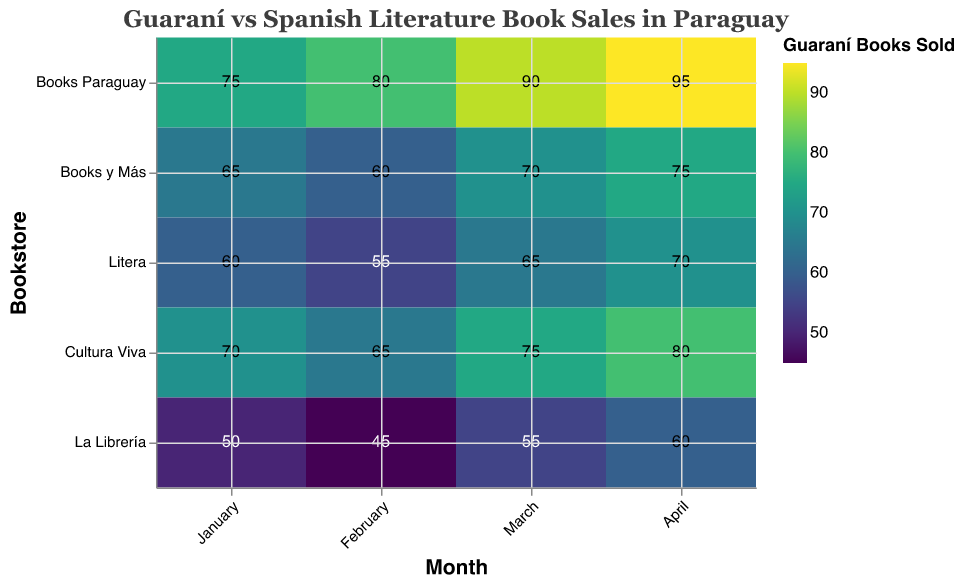What is the title of the chart? The title of the chart is displayed at the top and reads “Guaraní vs Spanish Literature Book Sales in Paraguay.”
Answer: Guaraní vs Spanish Literature Book Sales in Paraguay Which bookstore sold the most Guaraní literature books in April? Look for the highest rectangle in the column labeled "April". The bookstore with the highest value there is "Books Paraguay" with a value of 95.
Answer: Books Paraguay What is the total number of Guaraní literature books sold in January across all bookstores? Add the values for January in the Guaraní literature books sold column: 75 (Books Paraguay) + 65 (Books y Más) + 60 (Litera) + 70 (Cultura Viva) + 50 (La Librería) = 320.
Answer: 320 Which city shows the highest increase in Guaraní literature book sales from January to April? Calculate the difference for each city between January and April and find the largest increase: 
Asunción: 95 - 75 = 20
Encarnación: 75 - 65 = 10
San Lorenzo: 70 - 60 = 10
Ciudad del Este: 80 - 70 = 10
Luque: 60 - 50 = 10
Answer: Asunción Compared to January, how many more Guaraní literature books were sold in Asunción in March? Subtract the sales in January from those in March in Asunción: 90 - 75 = 15.
Answer: 15 Which month had the least number of Guaraní literature books sold in Litera? Look at the column for Litera and identify the smallest number in each month for Guaraní literature books sold. February has the smallest value of 55.
Answer: February How does the sales trend for Guaraní literature books compare between Books Paraguay and Books y Más over the four months? Compare the values month by month for both bookstores:
Books Paraguay: 75, 80, 90, 95
Books y Más: 65, 60, 70, 75
Both bookstores show an upward trend, although Books Paraguay has consistently higher sales and a more significant increase.
Answer: Both show an upward trend, Books Paraguay has higher sales and increase In which month did Cultura Viva have the highest sale of Guaraní literature books? Look for the peak value in the row corresponding to Cultura Viva for each month. April has the highest value of 80.
Answer: April Calculate the average monthly sales of Guaraní literature books in La Librería. Find the sales for each month in La Librería and calculate the average: (50 + 45 + 55 + 60) / 4 = 210 / 4 = 52.5.
Answer: 52.5 